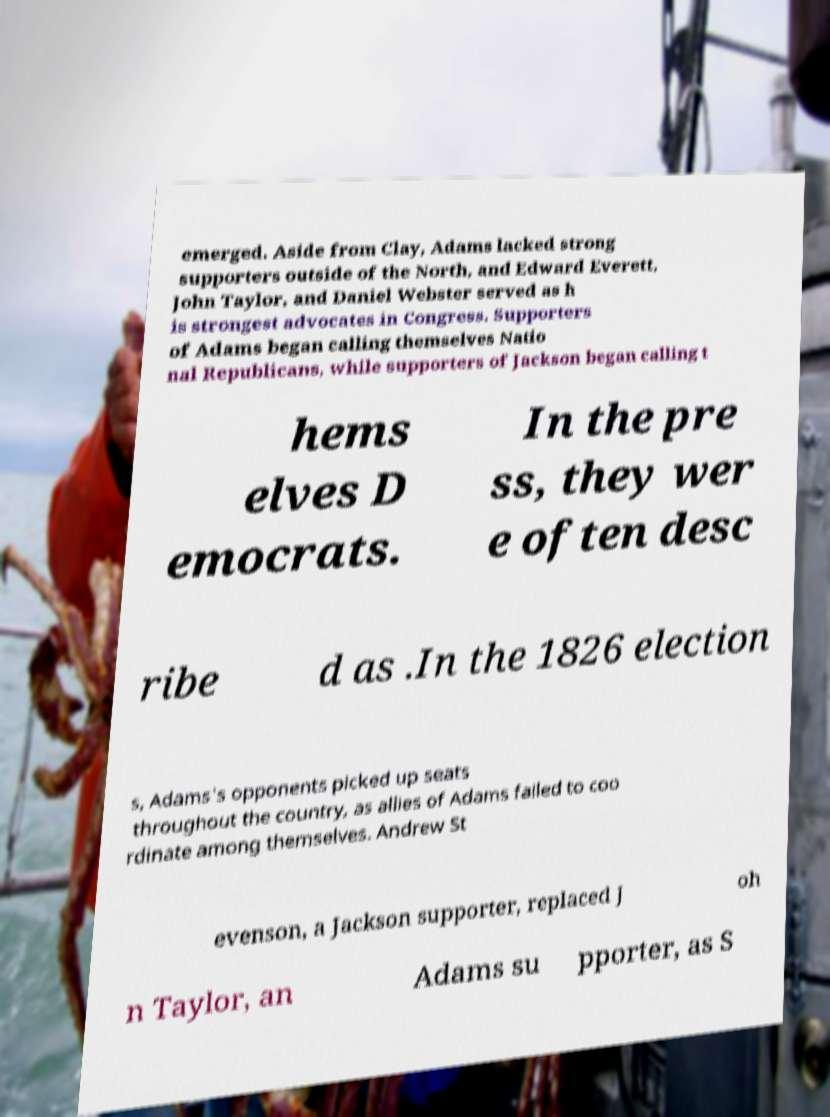Could you assist in decoding the text presented in this image and type it out clearly? emerged. Aside from Clay, Adams lacked strong supporters outside of the North, and Edward Everett, John Taylor, and Daniel Webster served as h is strongest advocates in Congress. Supporters of Adams began calling themselves Natio nal Republicans, while supporters of Jackson began calling t hems elves D emocrats. In the pre ss, they wer e often desc ribe d as .In the 1826 election s, Adams's opponents picked up seats throughout the country, as allies of Adams failed to coo rdinate among themselves. Andrew St evenson, a Jackson supporter, replaced J oh n Taylor, an Adams su pporter, as S 